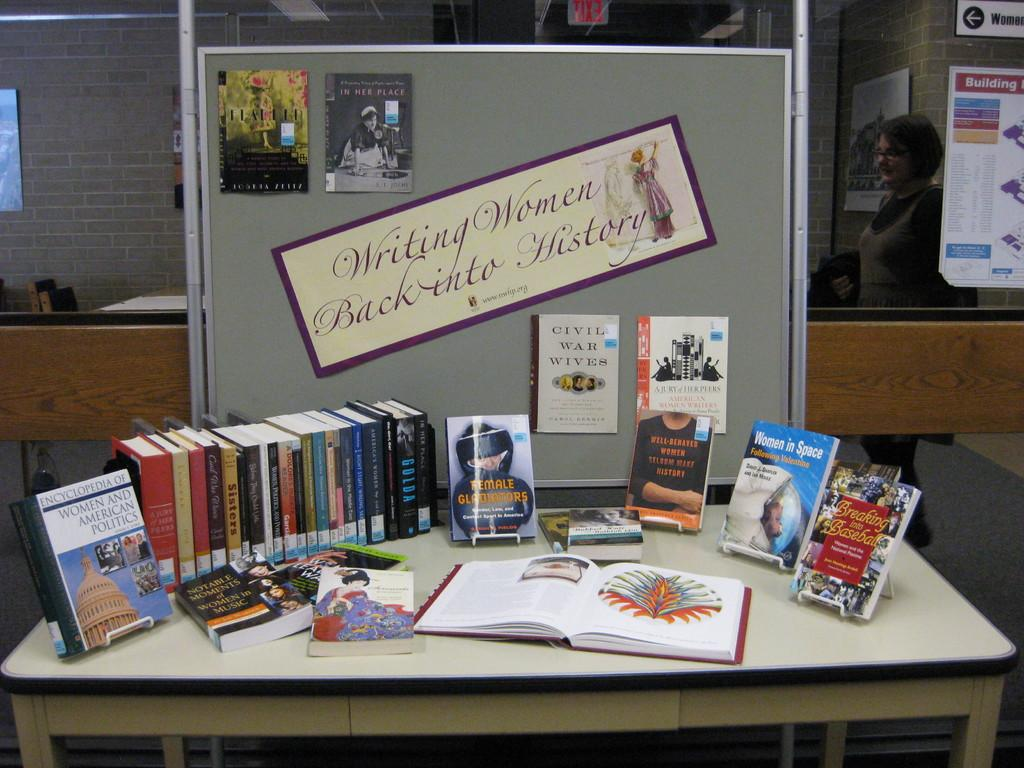Provide a one-sentence caption for the provided image. A display of books is arranged under a banner about women in history. 